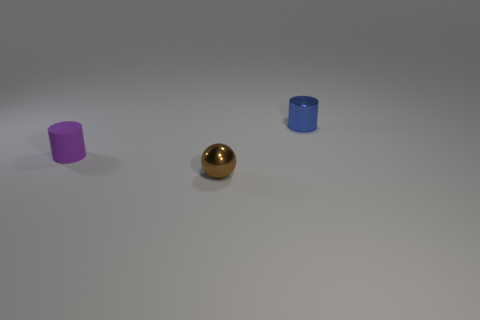Subtract all blue cylinders. How many cylinders are left? 1 Add 1 large gray things. How many objects exist? 4 Subtract all cylinders. How many objects are left? 1 Subtract 0 purple balls. How many objects are left? 3 Subtract all small red objects. Subtract all cylinders. How many objects are left? 1 Add 2 metallic objects. How many metallic objects are left? 4 Add 3 green matte blocks. How many green matte blocks exist? 3 